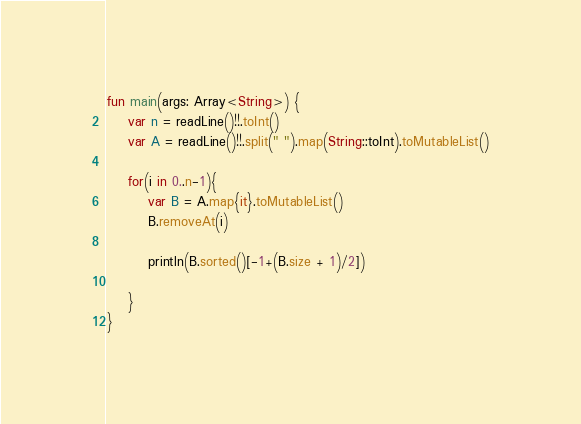<code> <loc_0><loc_0><loc_500><loc_500><_Kotlin_>fun main(args: Array<String>) {
    var n = readLine()!!.toInt()
    var A = readLine()!!.split(" ").map(String::toInt).toMutableList()

    for(i in 0..n-1){
        var B = A.map{it}.toMutableList()
        B.removeAt(i)
        
        println(B.sorted()[-1+(B.size + 1)/2])
    
    }
}</code> 